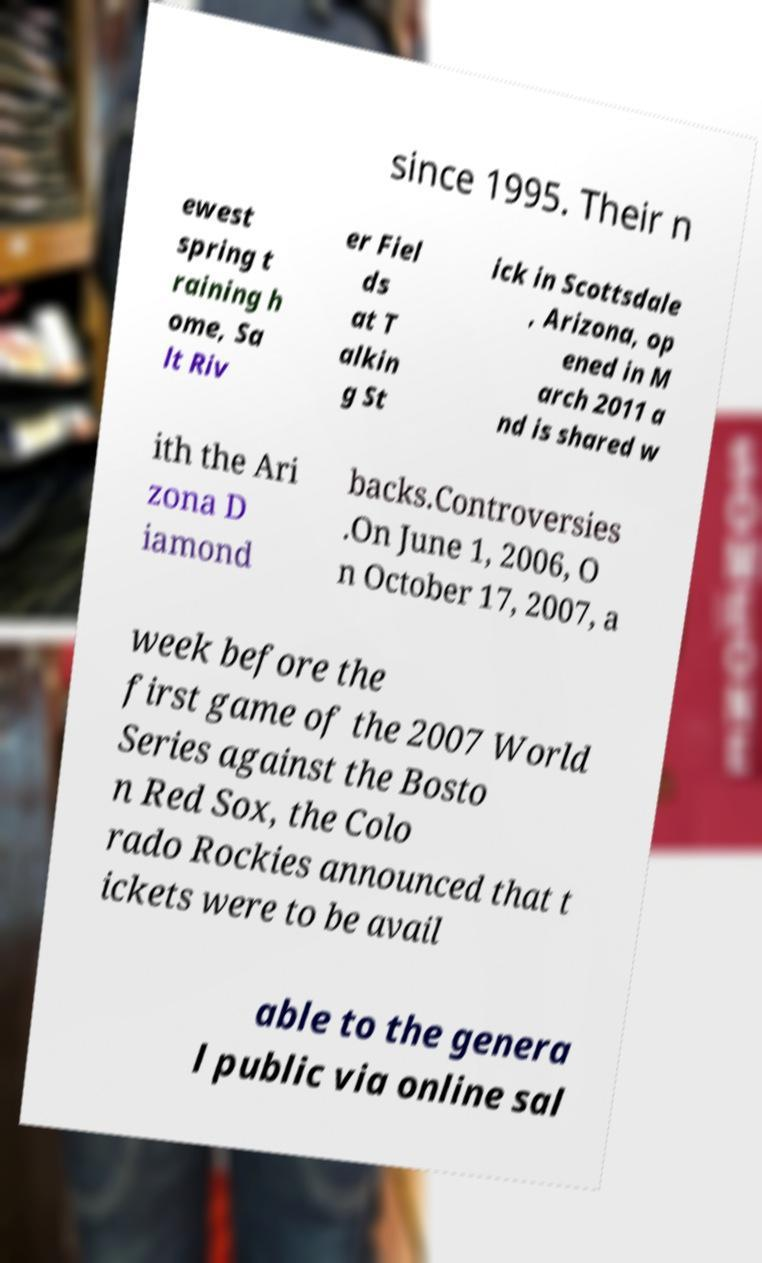There's text embedded in this image that I need extracted. Can you transcribe it verbatim? since 1995. Their n ewest spring t raining h ome, Sa lt Riv er Fiel ds at T alkin g St ick in Scottsdale , Arizona, op ened in M arch 2011 a nd is shared w ith the Ari zona D iamond backs.Controversies .On June 1, 2006, O n October 17, 2007, a week before the first game of the 2007 World Series against the Bosto n Red Sox, the Colo rado Rockies announced that t ickets were to be avail able to the genera l public via online sal 